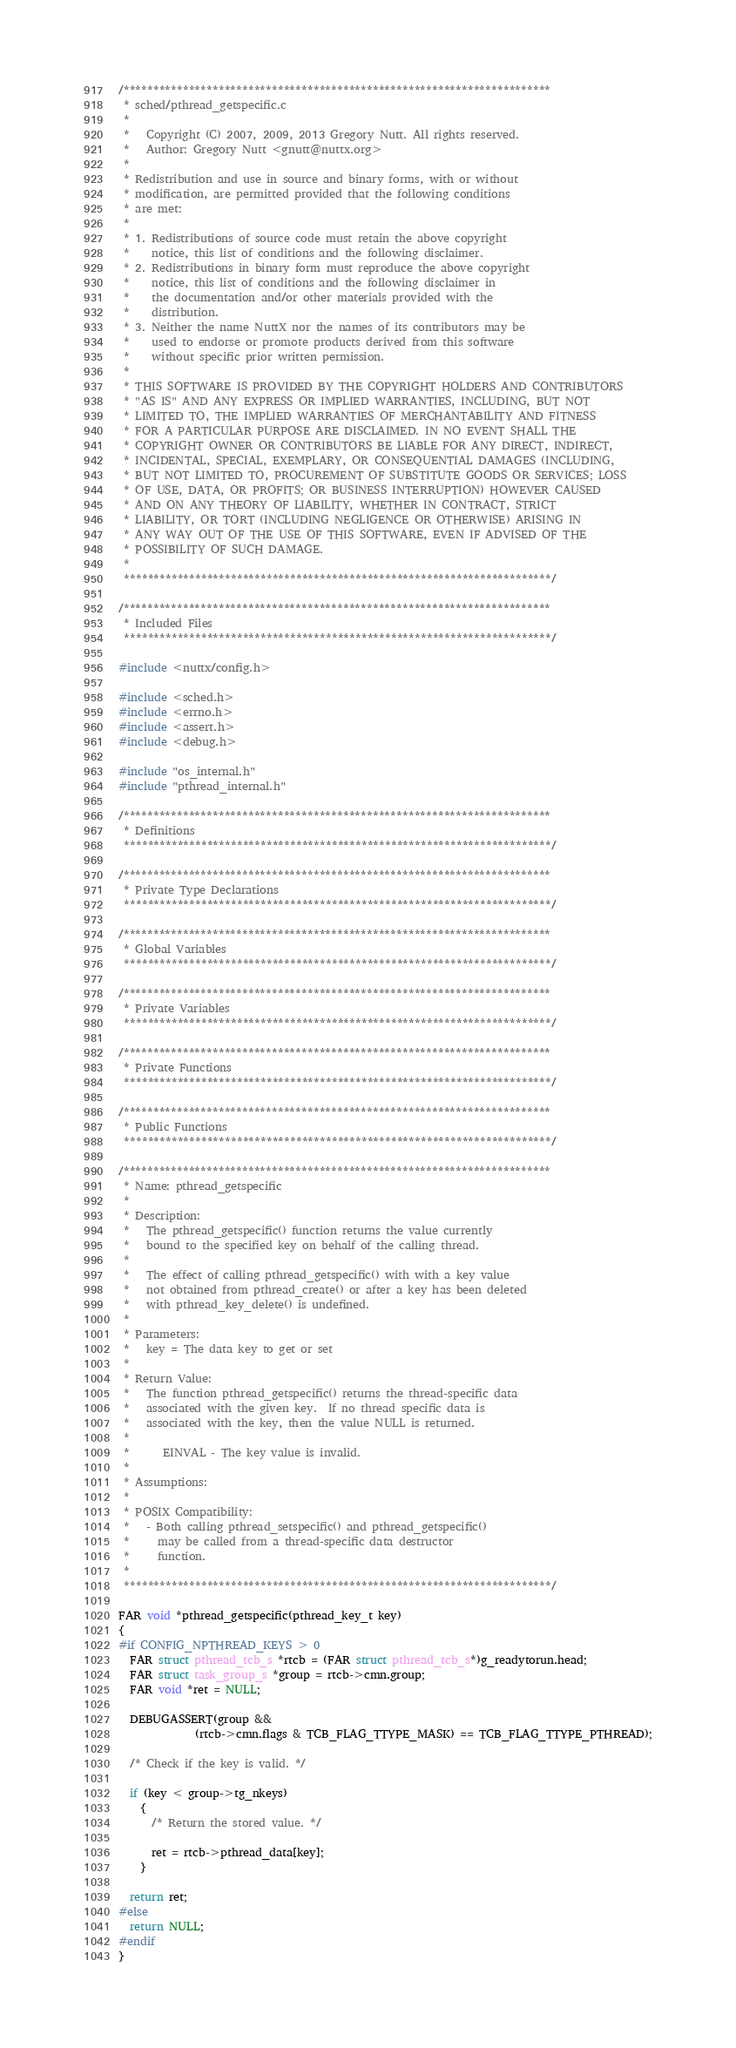Convert code to text. <code><loc_0><loc_0><loc_500><loc_500><_C_>/************************************************************************
 * sched/pthread_getspecific.c
 *
 *   Copyright (C) 2007, 2009, 2013 Gregory Nutt. All rights reserved.
 *   Author: Gregory Nutt <gnutt@nuttx.org>
 *
 * Redistribution and use in source and binary forms, with or without
 * modification, are permitted provided that the following conditions
 * are met:
 *
 * 1. Redistributions of source code must retain the above copyright
 *    notice, this list of conditions and the following disclaimer.
 * 2. Redistributions in binary form must reproduce the above copyright
 *    notice, this list of conditions and the following disclaimer in
 *    the documentation and/or other materials provided with the
 *    distribution.
 * 3. Neither the name NuttX nor the names of its contributors may be
 *    used to endorse or promote products derived from this software
 *    without specific prior written permission.
 *
 * THIS SOFTWARE IS PROVIDED BY THE COPYRIGHT HOLDERS AND CONTRIBUTORS
 * "AS IS" AND ANY EXPRESS OR IMPLIED WARRANTIES, INCLUDING, BUT NOT
 * LIMITED TO, THE IMPLIED WARRANTIES OF MERCHANTABILITY AND FITNESS
 * FOR A PARTICULAR PURPOSE ARE DISCLAIMED. IN NO EVENT SHALL THE
 * COPYRIGHT OWNER OR CONTRIBUTORS BE LIABLE FOR ANY DIRECT, INDIRECT,
 * INCIDENTAL, SPECIAL, EXEMPLARY, OR CONSEQUENTIAL DAMAGES (INCLUDING,
 * BUT NOT LIMITED TO, PROCUREMENT OF SUBSTITUTE GOODS OR SERVICES; LOSS
 * OF USE, DATA, OR PROFITS; OR BUSINESS INTERRUPTION) HOWEVER CAUSED
 * AND ON ANY THEORY OF LIABILITY, WHETHER IN CONTRACT, STRICT
 * LIABILITY, OR TORT (INCLUDING NEGLIGENCE OR OTHERWISE) ARISING IN
 * ANY WAY OUT OF THE USE OF THIS SOFTWARE, EVEN IF ADVISED OF THE
 * POSSIBILITY OF SUCH DAMAGE.
 *
 ************************************************************************/

/************************************************************************
 * Included Files
 ************************************************************************/

#include <nuttx/config.h>

#include <sched.h>
#include <errno.h>
#include <assert.h>
#include <debug.h>

#include "os_internal.h"
#include "pthread_internal.h"

/************************************************************************
 * Definitions
 ************************************************************************/

/************************************************************************
 * Private Type Declarations
 ************************************************************************/

/************************************************************************
 * Global Variables
 ************************************************************************/

/************************************************************************
 * Private Variables
 ************************************************************************/

/************************************************************************
 * Private Functions
 ************************************************************************/

/************************************************************************
 * Public Functions
 ************************************************************************/

/************************************************************************
 * Name: pthread_getspecific
 *
 * Description:
 *   The pthread_getspecific() function returns the value currently
 *   bound to the specified key on behalf of the calling thread.
 *
 *   The effect of calling pthread_getspecific() with with a key value
 *   not obtained from pthread_create() or after a key has been deleted
 *   with pthread_key_delete() is undefined.
 *
 * Parameters:
 *   key = The data key to get or set
 *
 * Return Value:
 *   The function pthread_getspecific() returns the thread-specific data
 *   associated with the given key.  If no thread specific data is
 *   associated with the key, then the value NULL is returned.
 *
 *      EINVAL - The key value is invalid.
 *
 * Assumptions:
 *
 * POSIX Compatibility:
 *   - Both calling pthread_setspecific() and pthread_getspecific()
 *     may be called from a thread-specific data destructor
 *     function.
 *
 ************************************************************************/

FAR void *pthread_getspecific(pthread_key_t key)
{
#if CONFIG_NPTHREAD_KEYS > 0
  FAR struct pthread_tcb_s *rtcb = (FAR struct pthread_tcb_s*)g_readytorun.head;
  FAR struct task_group_s *group = rtcb->cmn.group;
  FAR void *ret = NULL;

  DEBUGASSERT(group &&
              (rtcb->cmn.flags & TCB_FLAG_TTYPE_MASK) == TCB_FLAG_TTYPE_PTHREAD);

  /* Check if the key is valid. */

  if (key < group->tg_nkeys)
    {
      /* Return the stored value. */

      ret = rtcb->pthread_data[key];
    }

  return ret;
#else
  return NULL;
#endif
}

</code> 